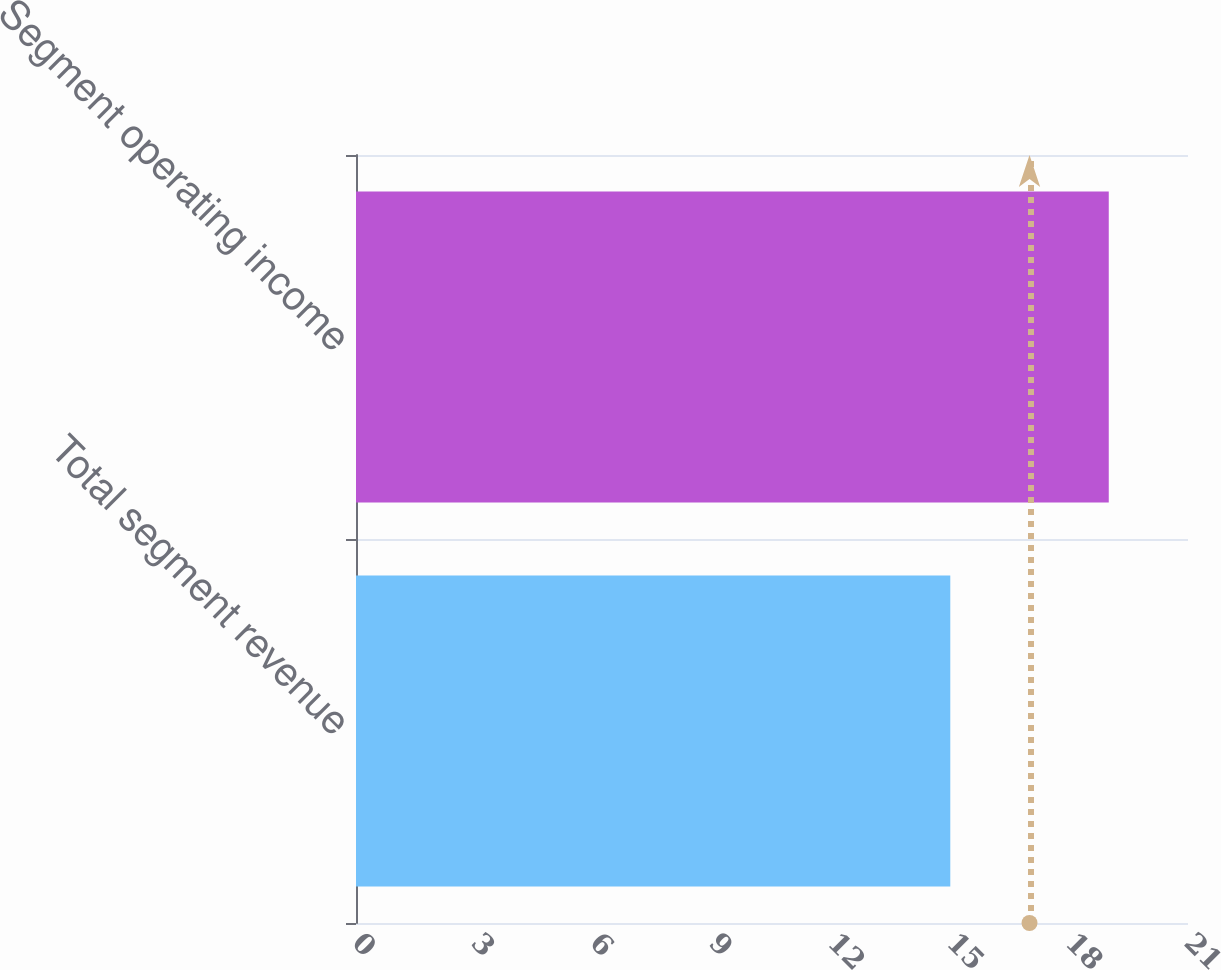<chart> <loc_0><loc_0><loc_500><loc_500><bar_chart><fcel>Total segment revenue<fcel>Segment operating income<nl><fcel>15<fcel>19<nl></chart> 